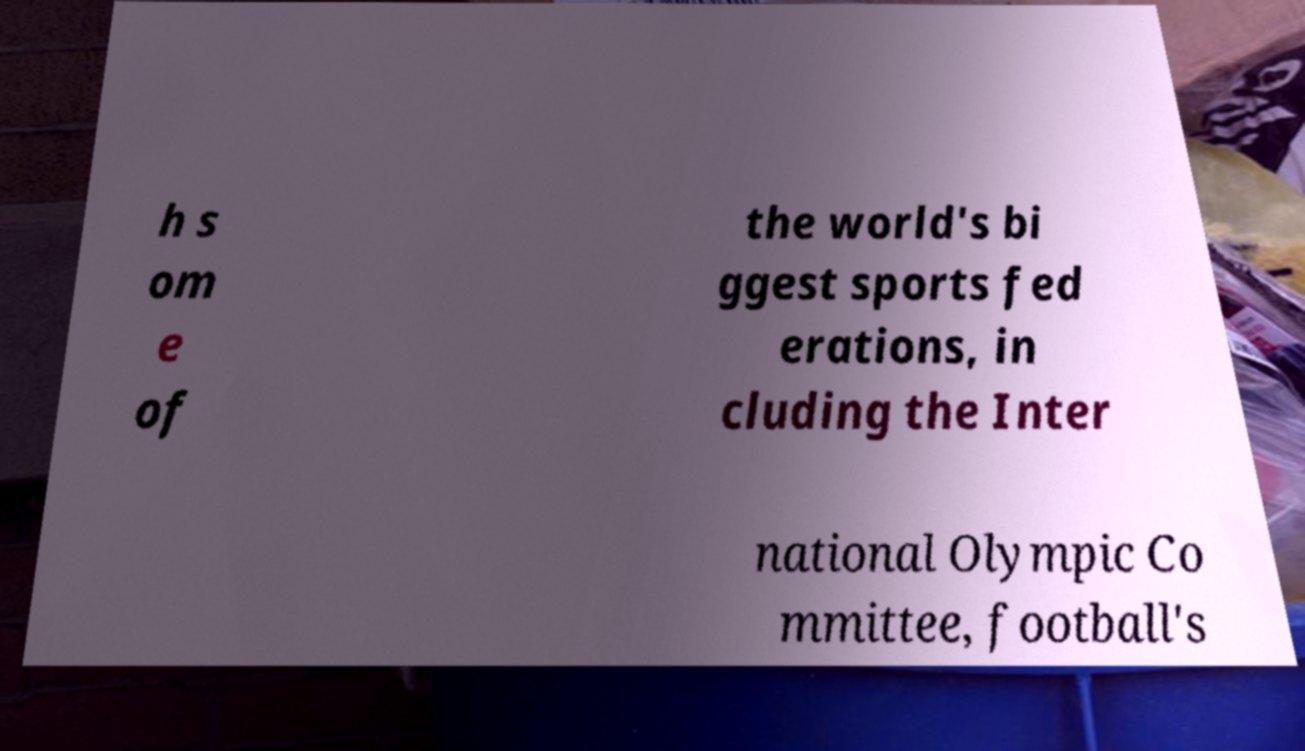There's text embedded in this image that I need extracted. Can you transcribe it verbatim? h s om e of the world's bi ggest sports fed erations, in cluding the Inter national Olympic Co mmittee, football's 